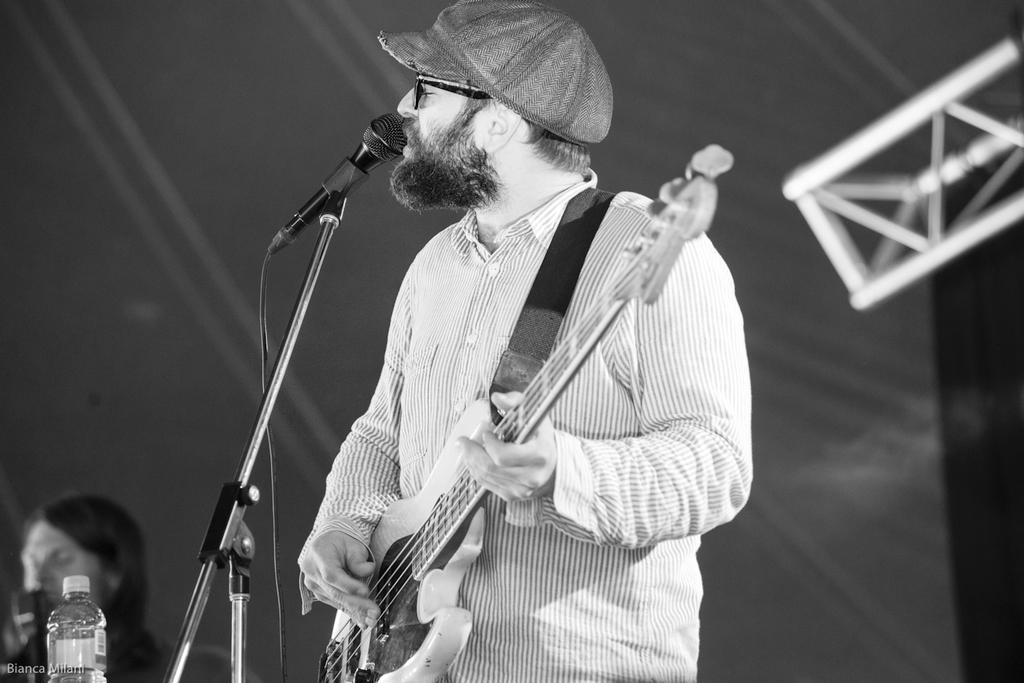Please provide a concise description of this image. There is a person wearing white color shirt playing guitar and there is also a microphone in front of him and at the left side of the image there is a bottle. 